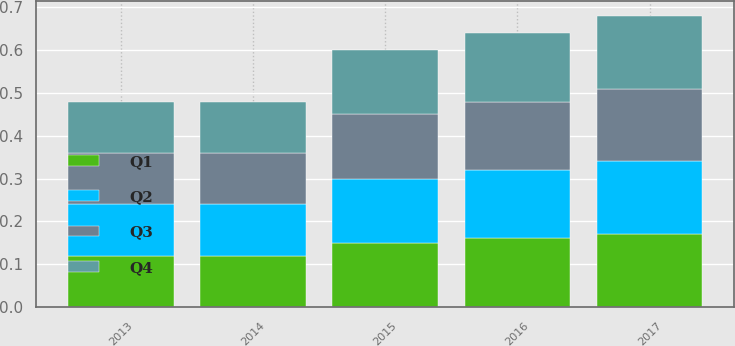Convert chart. <chart><loc_0><loc_0><loc_500><loc_500><stacked_bar_chart><ecel><fcel>2017<fcel>2016<fcel>2015<fcel>2014<fcel>2013<nl><fcel>Q4<fcel>0.17<fcel>0.16<fcel>0.15<fcel>0.12<fcel>0.12<nl><fcel>Q1<fcel>0.17<fcel>0.16<fcel>0.15<fcel>0.12<fcel>0.12<nl><fcel>Q3<fcel>0.17<fcel>0.16<fcel>0.15<fcel>0.12<fcel>0.12<nl><fcel>Q2<fcel>0.17<fcel>0.16<fcel>0.15<fcel>0.12<fcel>0.12<nl></chart> 